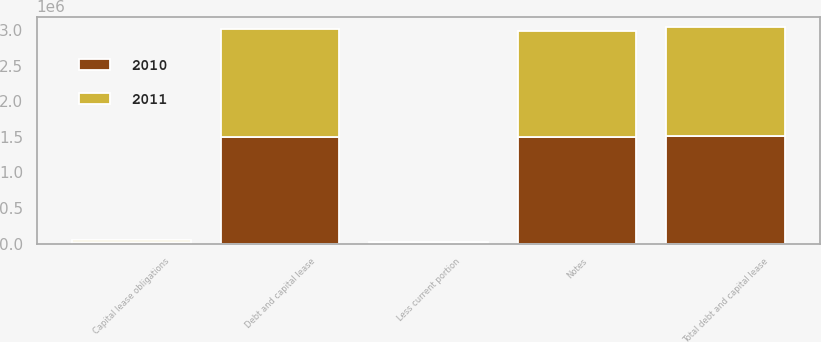Convert chart to OTSL. <chart><loc_0><loc_0><loc_500><loc_500><stacked_bar_chart><ecel><fcel>Notes<fcel>Capital lease obligations<fcel>Total debt and capital lease<fcel>Less current portion<fcel>Debt and capital lease<nl><fcel>2010<fcel>1.49463e+06<fcel>19681<fcel>1.51431e+06<fcel>9212<fcel>1.5051e+06<nl><fcel>2011<fcel>1.49397e+06<fcel>28492<fcel>1.52246e+06<fcel>8799<fcel>1.51366e+06<nl></chart> 